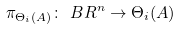Convert formula to latex. <formula><loc_0><loc_0><loc_500><loc_500>\pi _ { \Theta _ { i } ( A ) } \colon \ B R ^ { n } \to \Theta _ { i } ( A )</formula> 